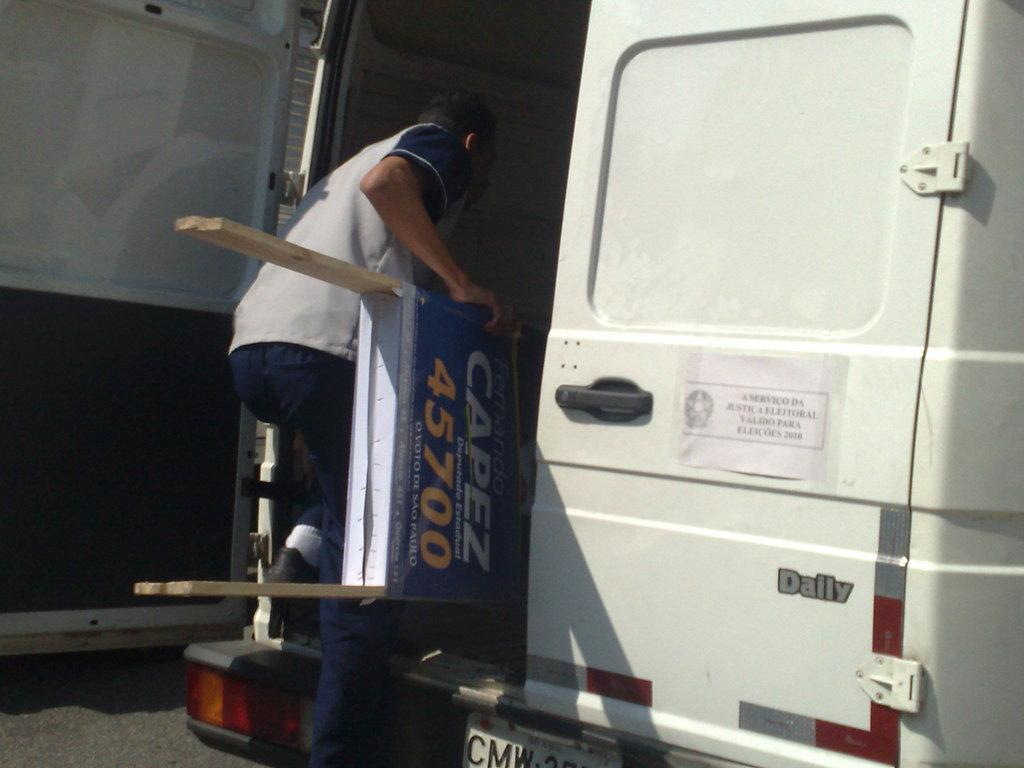Who is the person in the image? The image shows a person holding a hoarding. What is the person doing with the hoarding? The person is getting into a vehicle while holding the hoarding. Can you describe the vehicle in the image? The vehicle has a sign pasted on it, a number plate, and lights. It is on the road. What might the sign on the vehicle indicate? The sign on the vehicle could indicate the purpose or affiliation of the vehicle. What type of income can be seen in the image? There is no indication of income in the image; it features a person holding a hoarding and getting into a vehicle. What discovery was made by the band in the image? There is no band or discovery mentioned in the image. 